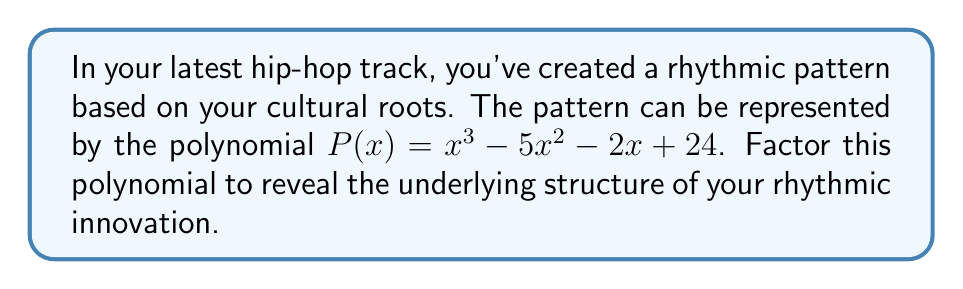Give your solution to this math problem. Let's approach this step-by-step:

1) First, we'll check if there are any rational roots using the rational root theorem. The possible rational roots are the factors of the constant term: $\pm 1, \pm 2, \pm 3, \pm 4, \pm 6, \pm 8, \pm 12, \pm 24$.

2) Testing these, we find that $x = 4$ is a root of the polynomial.

3) We can then divide $P(x)$ by $(x - 4)$ using polynomial long division:

   $x^3 - 5x^2 - 2x + 24 = (x - 4)(x^2 - x - 6)$

4) Now we need to factor the quadratic term $x^2 - x - 6$. We can do this by finding two numbers that multiply to give -6 and add to give -1.

5) These numbers are -3 and 2.

6) Therefore, $x^2 - x - 6 = (x - 3)(x + 2)$

7) Putting it all together:

   $P(x) = x^3 - 5x^2 - 2x + 24 = (x - 4)(x - 3)(x + 2)$

This factorization reveals the underlying structure of your rhythmic pattern, with each factor representing a distinct rhythmic element influenced by your cultural background.
Answer: $P(x) = (x - 4)(x - 3)(x + 2)$ 